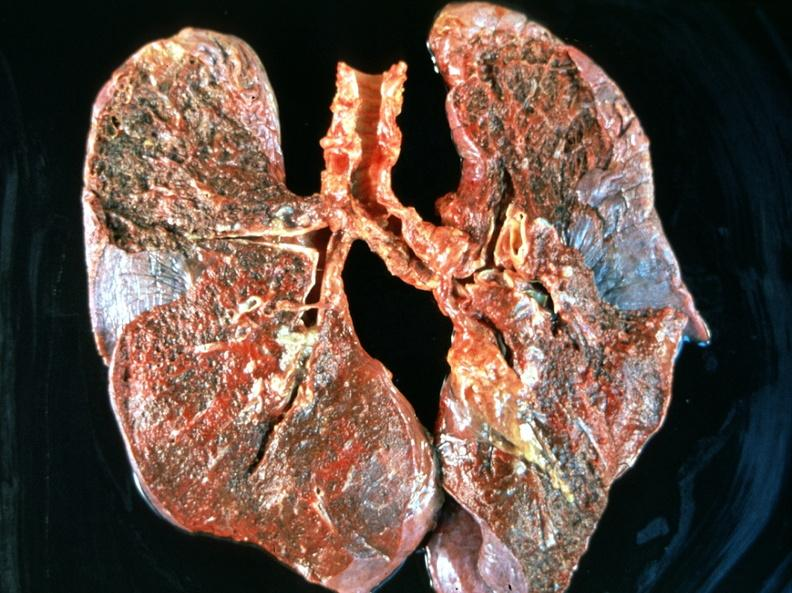where is this?
Answer the question using a single word or phrase. Lung 